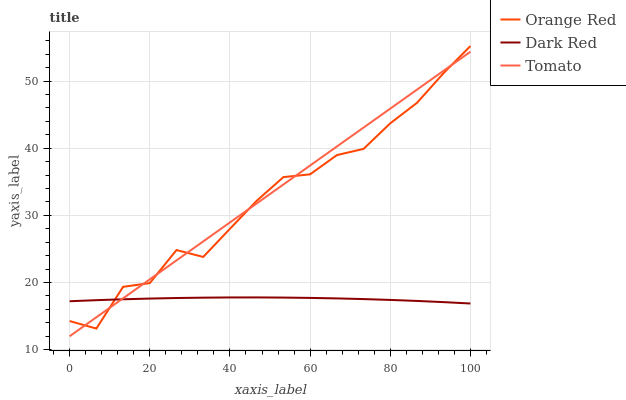Does Dark Red have the minimum area under the curve?
Answer yes or no. Yes. Does Tomato have the maximum area under the curve?
Answer yes or no. Yes. Does Orange Red have the minimum area under the curve?
Answer yes or no. No. Does Orange Red have the maximum area under the curve?
Answer yes or no. No. Is Tomato the smoothest?
Answer yes or no. Yes. Is Orange Red the roughest?
Answer yes or no. Yes. Is Dark Red the smoothest?
Answer yes or no. No. Is Dark Red the roughest?
Answer yes or no. No. Does Tomato have the lowest value?
Answer yes or no. Yes. Does Orange Red have the lowest value?
Answer yes or no. No. Does Orange Red have the highest value?
Answer yes or no. Yes. Does Dark Red have the highest value?
Answer yes or no. No. Does Orange Red intersect Dark Red?
Answer yes or no. Yes. Is Orange Red less than Dark Red?
Answer yes or no. No. Is Orange Red greater than Dark Red?
Answer yes or no. No. 